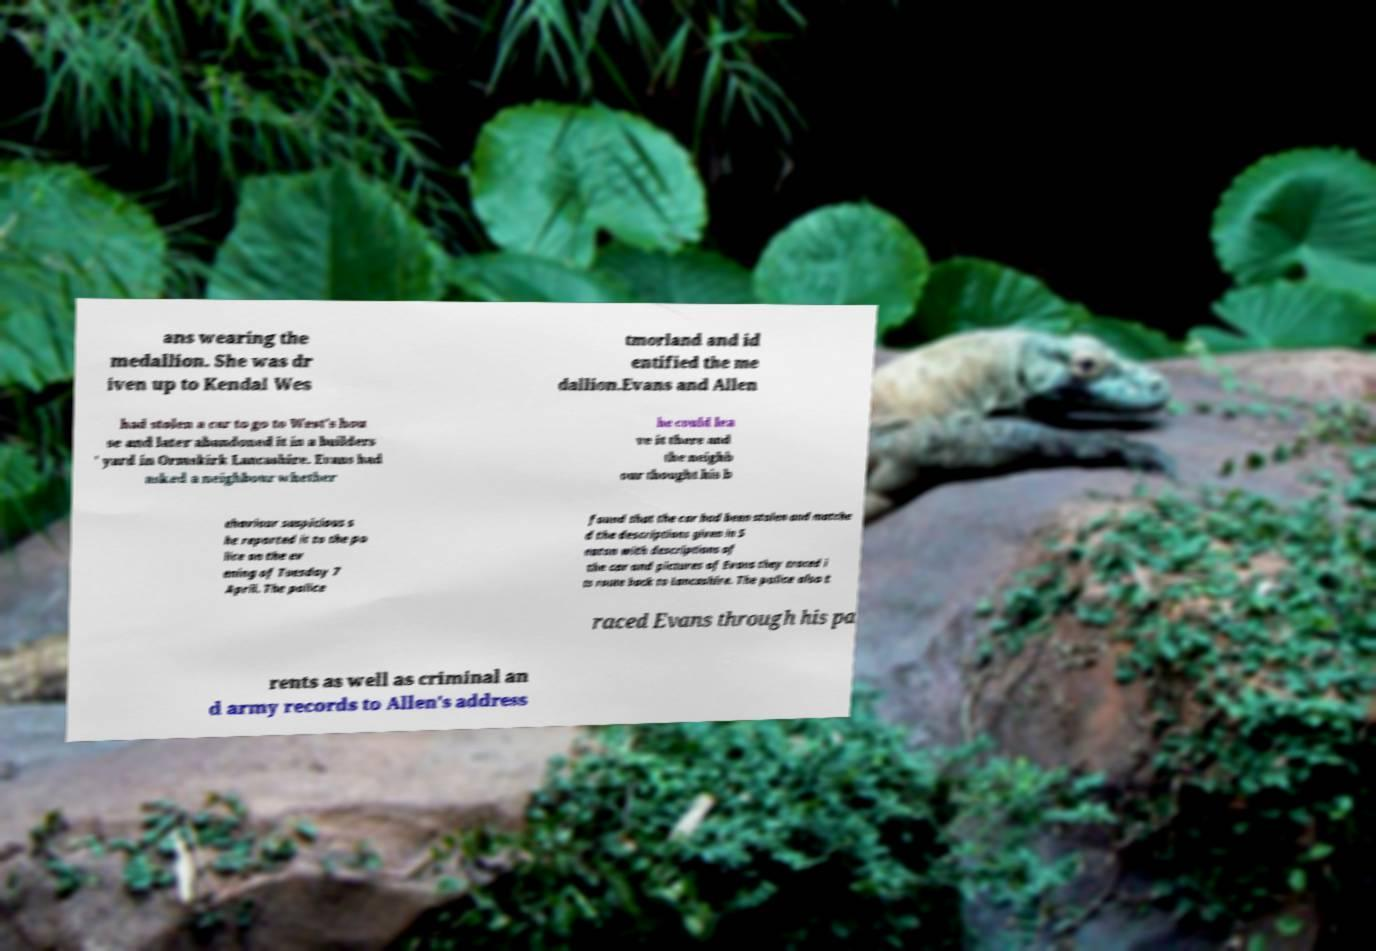Could you assist in decoding the text presented in this image and type it out clearly? ans wearing the medallion. She was dr iven up to Kendal Wes tmorland and id entified the me dallion.Evans and Allen had stolen a car to go to West's hou se and later abandoned it in a builders ' yard in Ormskirk Lancashire. Evans had asked a neighbour whether he could lea ve it there and the neighb our thought his b ehaviour suspicious s he reported it to the po lice on the ev ening of Tuesday 7 April. The police found that the car had been stolen and matche d the descriptions given in S eaton with descriptions of the car and pictures of Evans they traced i ts route back to Lancashire. The police also t raced Evans through his pa rents as well as criminal an d army records to Allen's address 